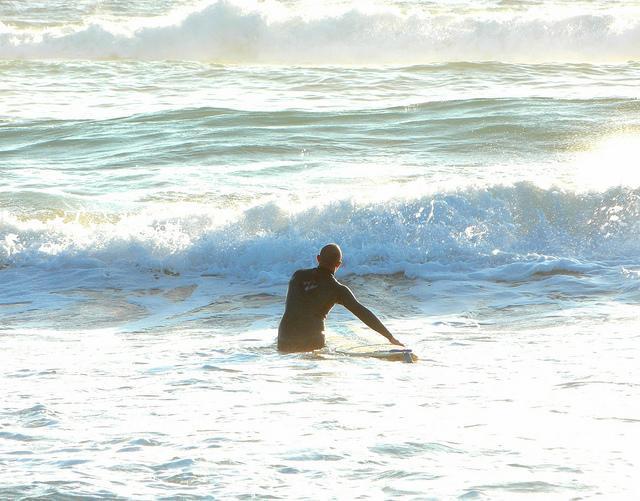World surf league is the highest governing body of which sport?
Select the accurate answer and provide justification: `Answer: choice
Rationale: srationale.`
Options: Kiting, swimming, skating, surfing. Answer: surfing.
Rationale: The man is holding a surfboard. 